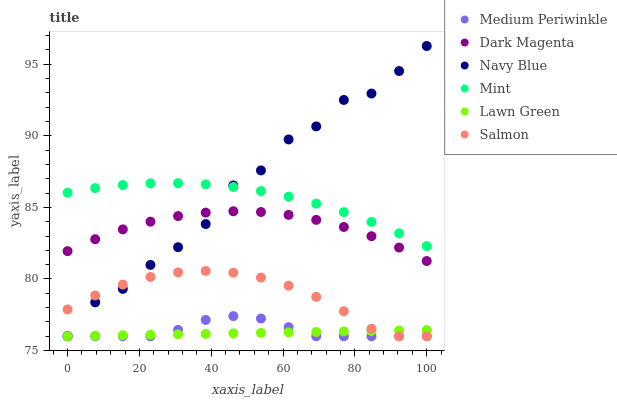Does Lawn Green have the minimum area under the curve?
Answer yes or no. Yes. Does Navy Blue have the maximum area under the curve?
Answer yes or no. Yes. Does Dark Magenta have the minimum area under the curve?
Answer yes or no. No. Does Dark Magenta have the maximum area under the curve?
Answer yes or no. No. Is Lawn Green the smoothest?
Answer yes or no. Yes. Is Navy Blue the roughest?
Answer yes or no. Yes. Is Dark Magenta the smoothest?
Answer yes or no. No. Is Dark Magenta the roughest?
Answer yes or no. No. Does Lawn Green have the lowest value?
Answer yes or no. Yes. Does Dark Magenta have the lowest value?
Answer yes or no. No. Does Navy Blue have the highest value?
Answer yes or no. Yes. Does Dark Magenta have the highest value?
Answer yes or no. No. Is Salmon less than Dark Magenta?
Answer yes or no. Yes. Is Mint greater than Medium Periwinkle?
Answer yes or no. Yes. Does Navy Blue intersect Mint?
Answer yes or no. Yes. Is Navy Blue less than Mint?
Answer yes or no. No. Is Navy Blue greater than Mint?
Answer yes or no. No. Does Salmon intersect Dark Magenta?
Answer yes or no. No. 